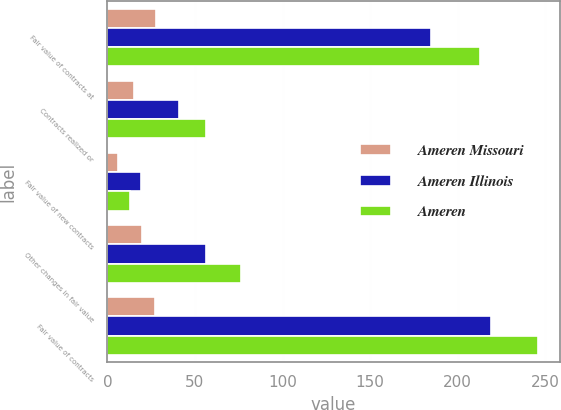<chart> <loc_0><loc_0><loc_500><loc_500><stacked_bar_chart><ecel><fcel>Fair value of contracts at<fcel>Contracts realized or<fcel>Fair value of new contracts<fcel>Other changes in fair value<fcel>Fair value of contracts<nl><fcel>Ameren Missouri<fcel>28<fcel>15<fcel>6<fcel>20<fcel>27<nl><fcel>Ameren Illinois<fcel>185<fcel>41<fcel>19<fcel>56<fcel>219<nl><fcel>Ameren<fcel>213<fcel>56<fcel>13<fcel>76<fcel>246<nl></chart> 